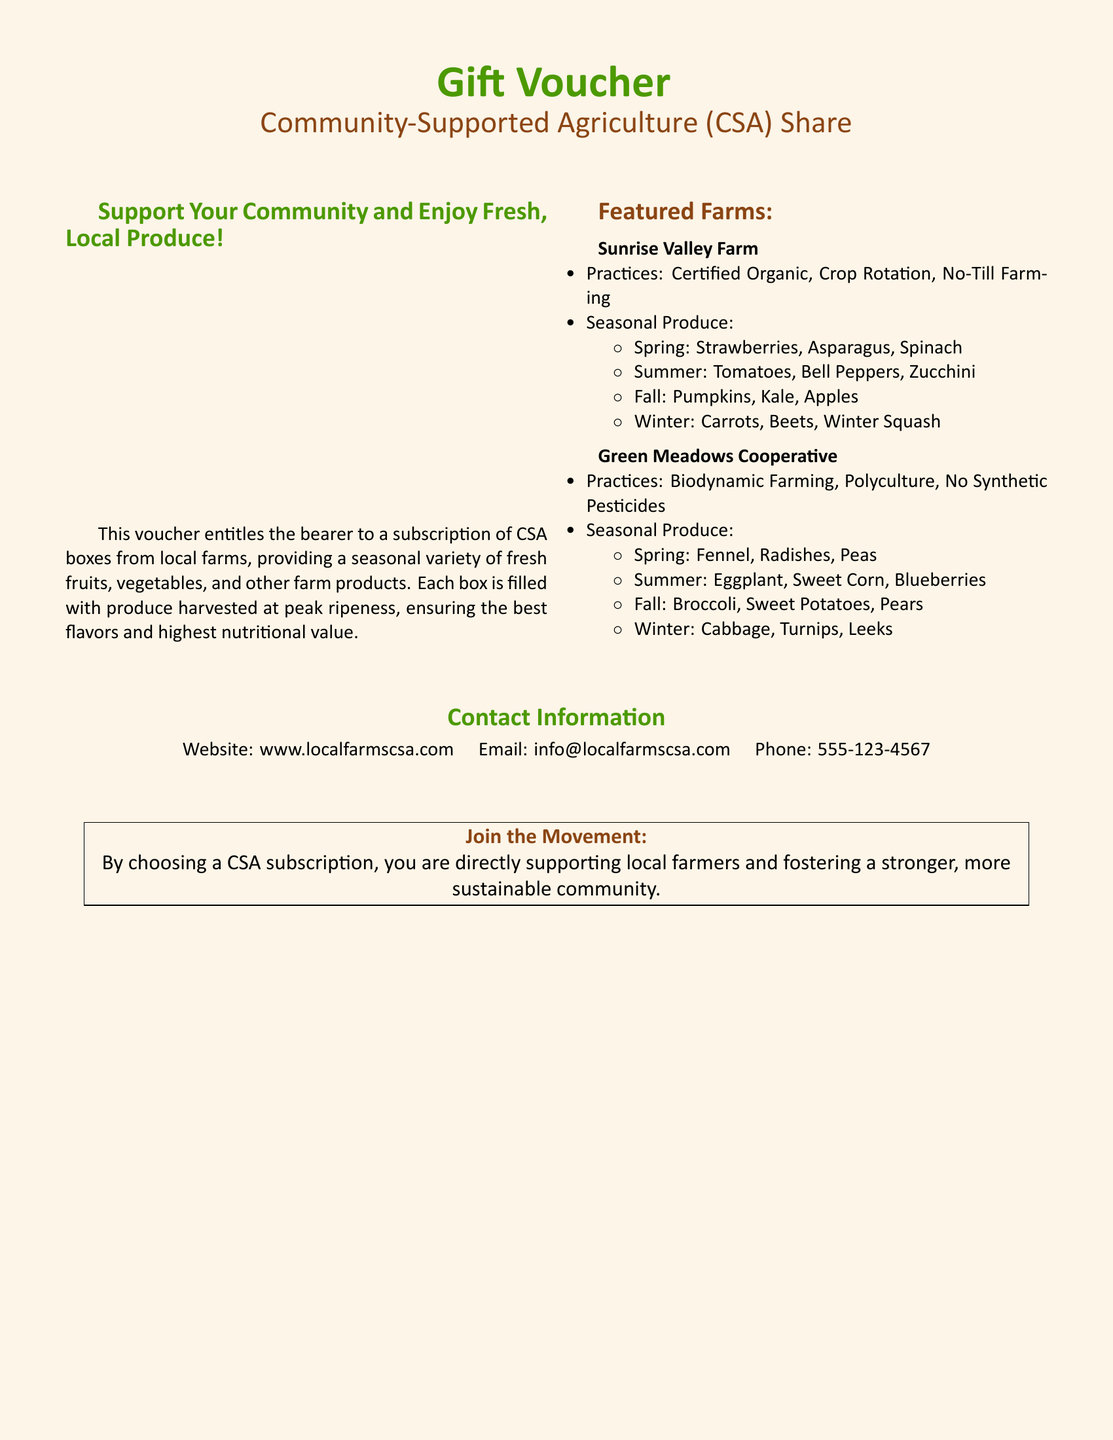What is the title of the voucher? The title is prominently displayed at the top of the document, indicating the purpose of the voucher.
Answer: Gift Voucher What is the seasonal produce available in Spring at Sunrise Valley Farm? This information is listed under the seasonal produce section for Sunrise Valley Farm.
Answer: Strawberries, Asparagus, Spinach Which farming practice is used by Green Meadows Cooperative? This is specified under the practices listed for Green Meadows Cooperative.
Answer: Biodynamic Farming How many farms are featured in the voucher? The number of farms is counted based on the sections provided in the document.
Answer: 2 What is the website provided for more information? The website is listed under the contact information section of the document.
Answer: www.localfarmscsa.com What does the voucher support? This is mentioned in the introductory text of the document explaining the benefits of the CSA subscription.
Answer: Local farmers What are the vegetables available in Winter at Sunrise Valley Farm? The Winter seasonal produce is specified in the document under Sunrise Valley Farm.
Answer: Carrots, Beets, Winter Squash What is the contact email provided in the voucher? The contact email is clearly stated in the contact section of the document.
Answer: info@localfarmscsa.com 